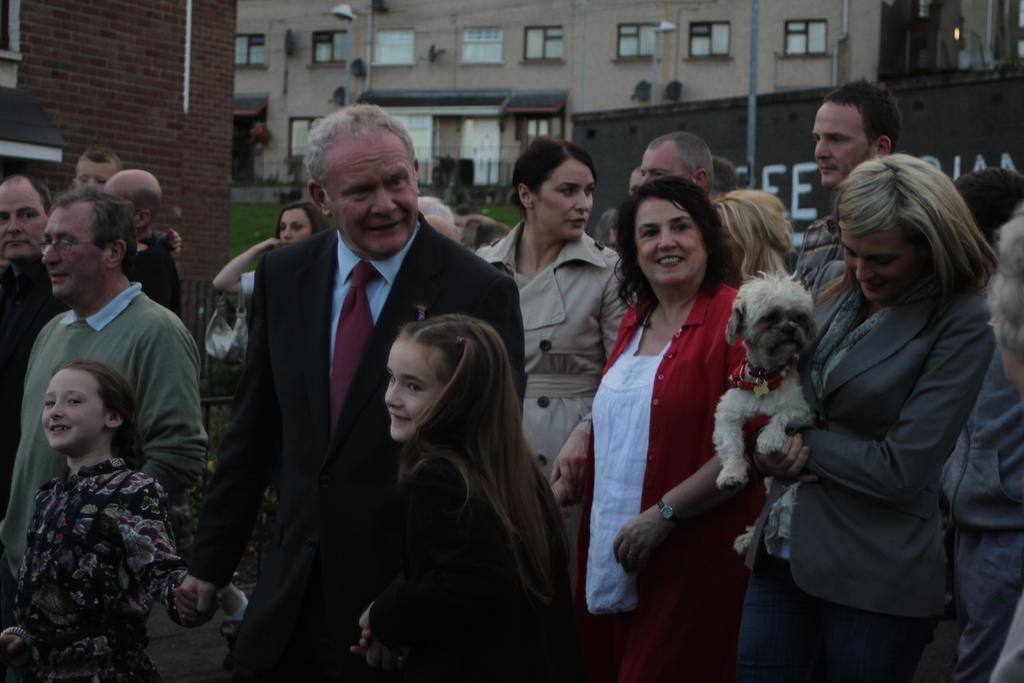Can you describe this image briefly? In this picture there are many people standing on the road where a lady to the right side of the image is holding a white dog and beside her there is a lady who is wearing red dress. There is also a guy who is holding two kids and in the background we observe many trees. 